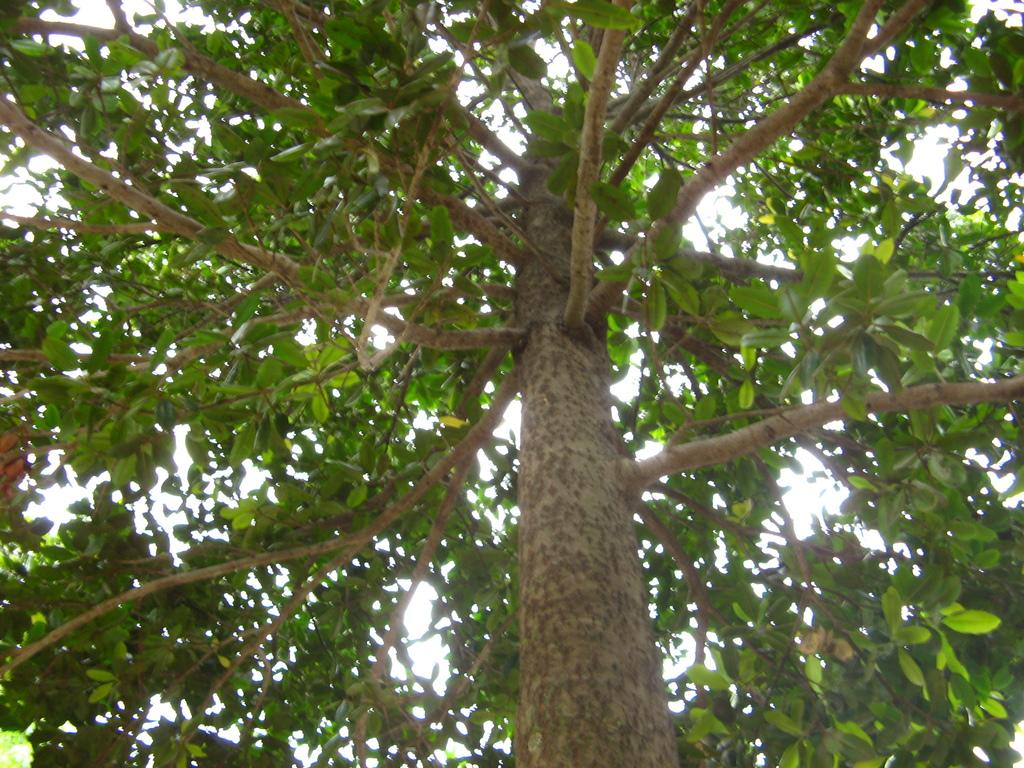What is the main object in the image? There is a tree in the image. Can you describe the colors of the tree? The tree has green and brown colors. What can be seen in the background of the image? The sky is visible in the background of the image. Can you see a man shaking hands with someone in the image? There is no man or handshake present in the image; it only features a tree with green and brown colors against a visible sky background. 